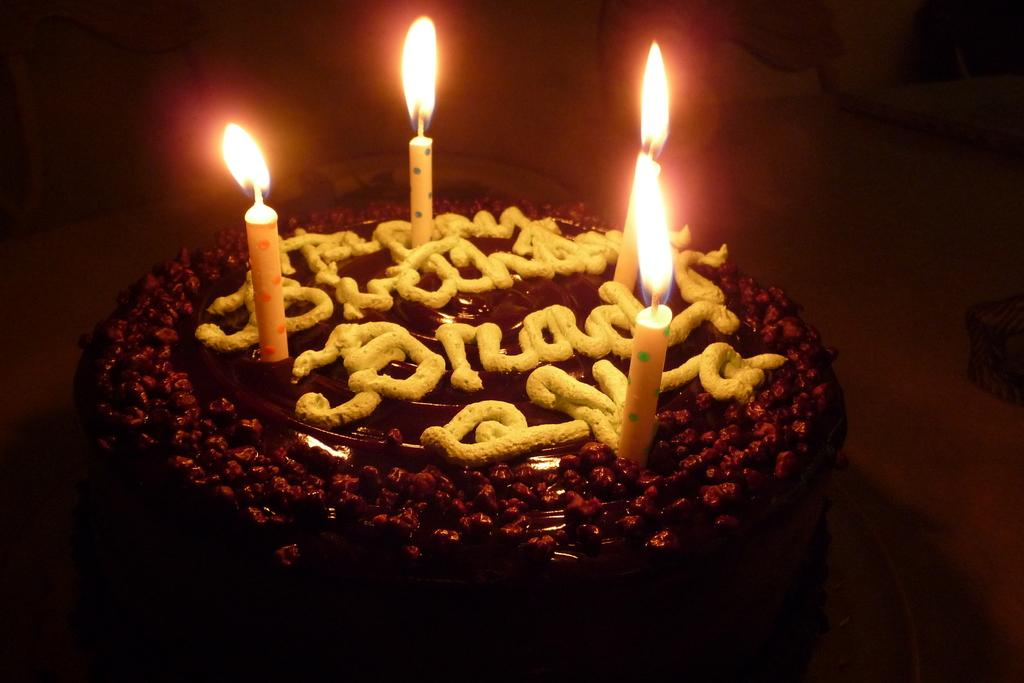What is the main subject of the image? There is a cake in the image. How many candles are on the cake? There are four candles on the cake. Can you describe the overall appearance of the image? The corners of the image are blurred. What type of space theory is being discussed in the image? There is no discussion of space theory in the image; it features a cake with four candles and blurred corners. How many bits are visible in the image? There are no bits present in the image. 